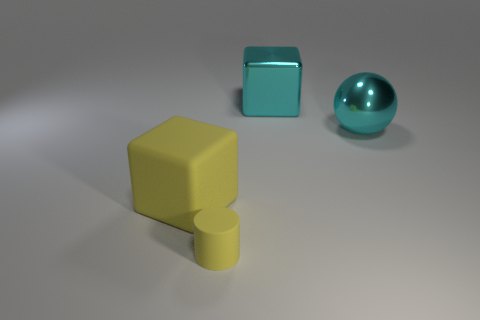Add 4 metallic objects. How many objects exist? 8 Subtract all spheres. How many objects are left? 3 Subtract 0 blue cylinders. How many objects are left? 4 Subtract all cyan cylinders. Subtract all large objects. How many objects are left? 1 Add 1 small matte cylinders. How many small matte cylinders are left? 2 Add 3 big shiny blocks. How many big shiny blocks exist? 4 